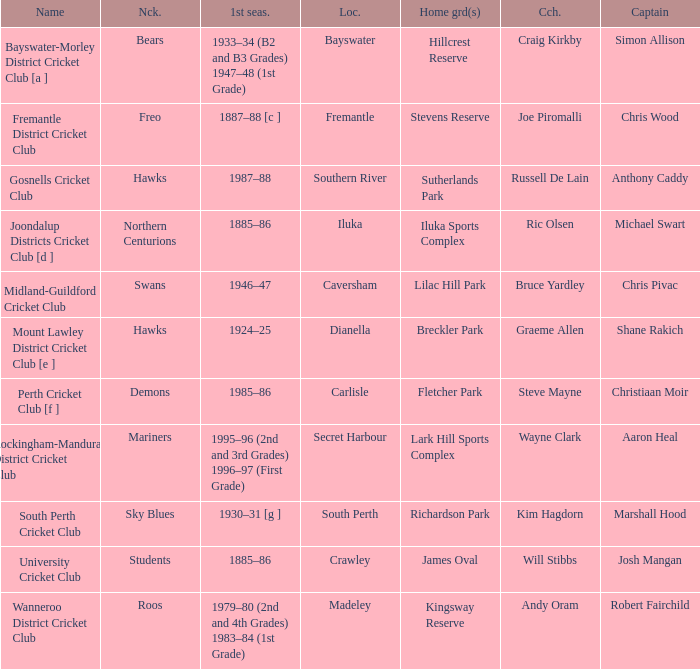For location Caversham, what is the name of the captain? Chris Pivac. 